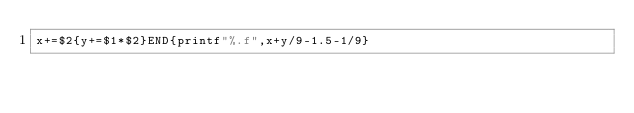<code> <loc_0><loc_0><loc_500><loc_500><_Awk_>x+=$2{y+=$1*$2}END{printf"%.f",x+y/9-1.5-1/9}</code> 